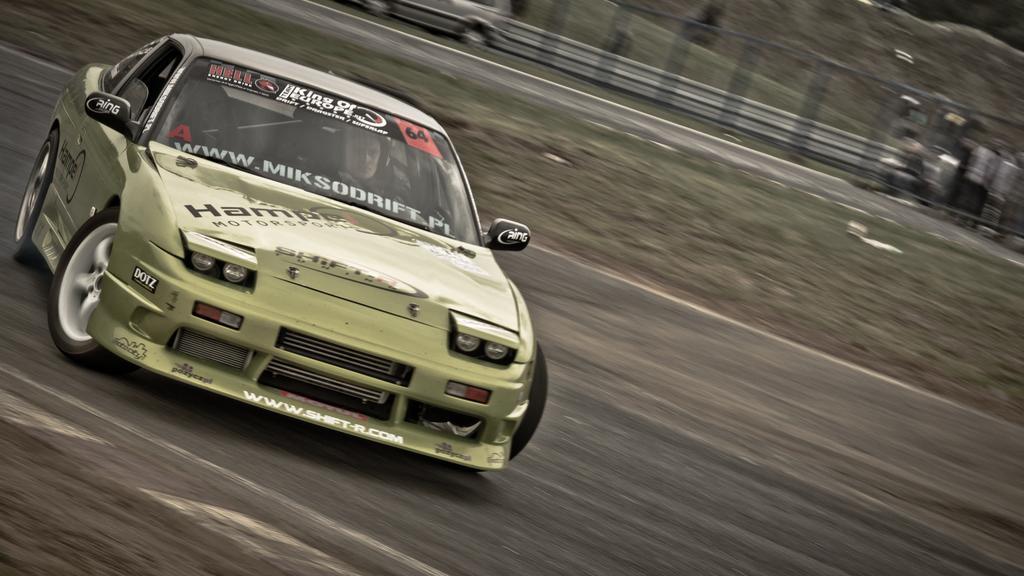In one or two sentences, can you explain what this image depicts? In this image, we can see a person inside the car. In the background, there is a fence and we can see an other vehicle and some stands. At the bottom, there is a road and there is ground. 